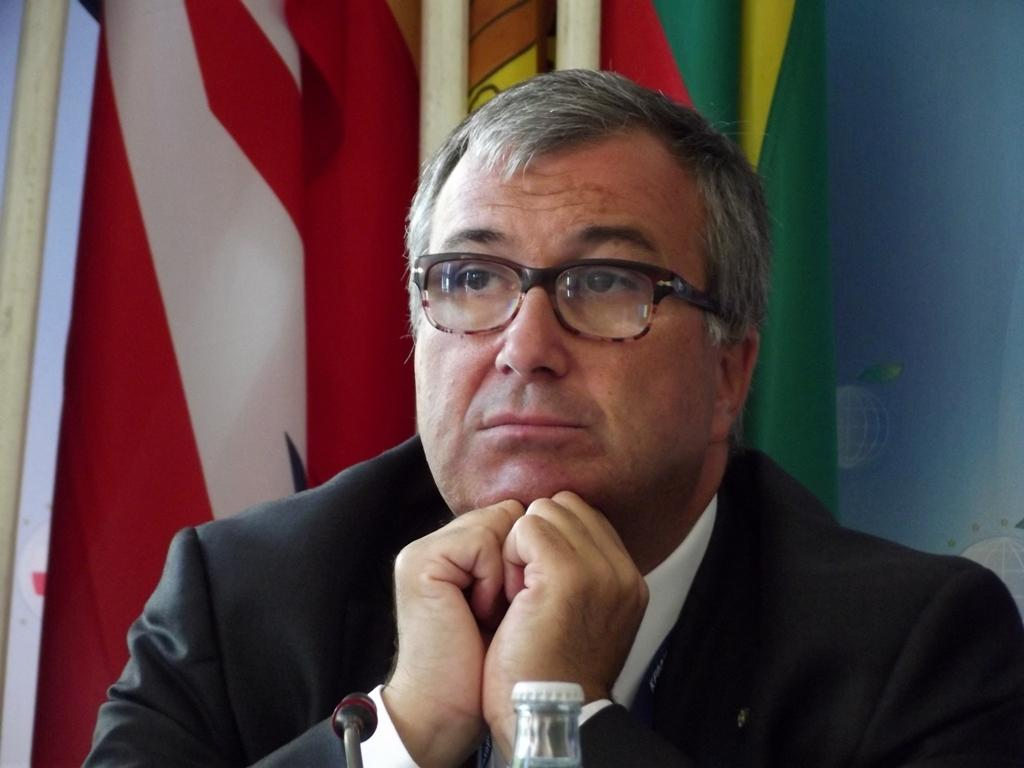Who is present in the image? There is a man in the image. What is the man doing in the image? The man is sitting. What is the man wearing in the image? The man is wearing a black suit. What can be seen in the background of the image? There is a flag pole in the background of the image. What type of duck can be seen flying in the image? There is no duck present in the image; it only features a man sitting and wearing a black suit, with a flag pole in the background. 